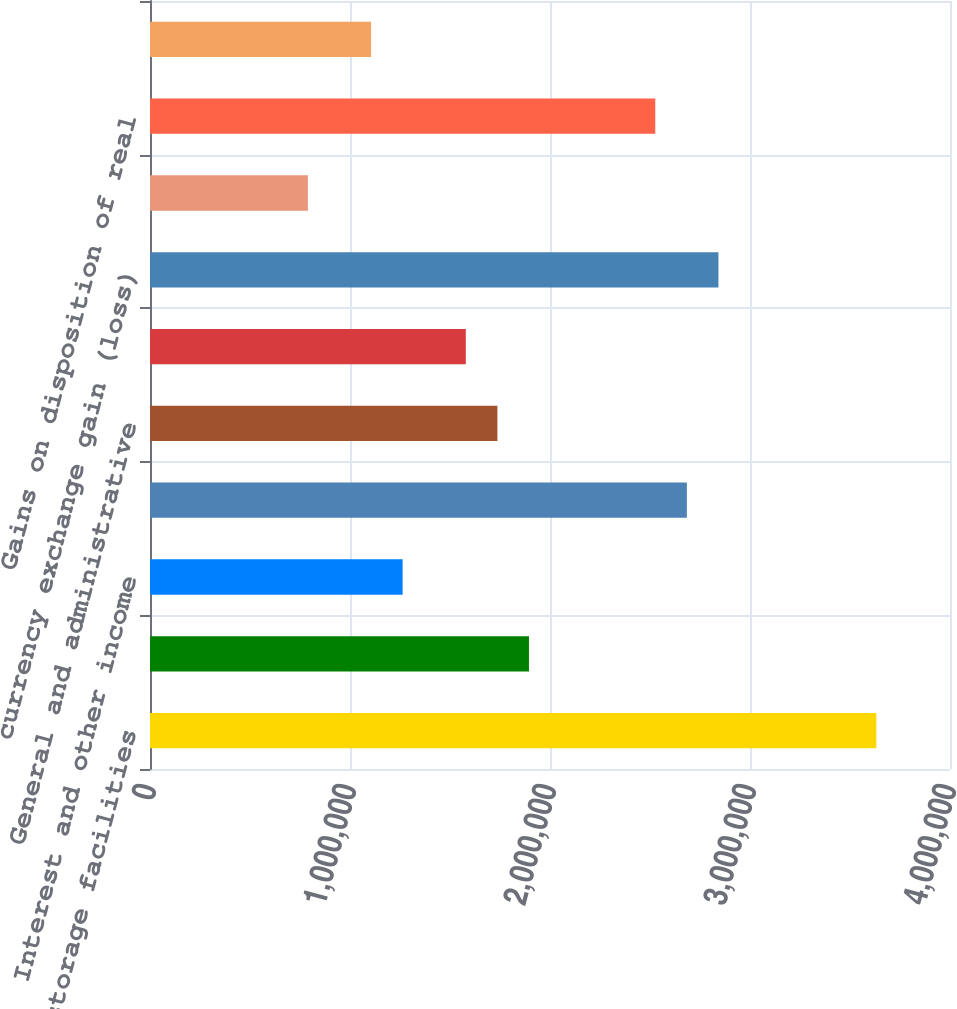<chart> <loc_0><loc_0><loc_500><loc_500><bar_chart><fcel>Self-storage facilities<fcel>Ancillary operations<fcel>Interest and other income<fcel>Depreciation and amortization<fcel>General and administrative<fcel>Interest expense<fcel>currency exchange gain (loss)<fcel>Equity in earnings of real<fcel>Gains on disposition of real<fcel>Foreign currency exchange gain<nl><fcel>3.63174e+06<fcel>1.89482e+06<fcel>1.26321e+06<fcel>2.68433e+06<fcel>1.73692e+06<fcel>1.57902e+06<fcel>2.84223e+06<fcel>789510<fcel>2.52643e+06<fcel>1.10531e+06<nl></chart> 